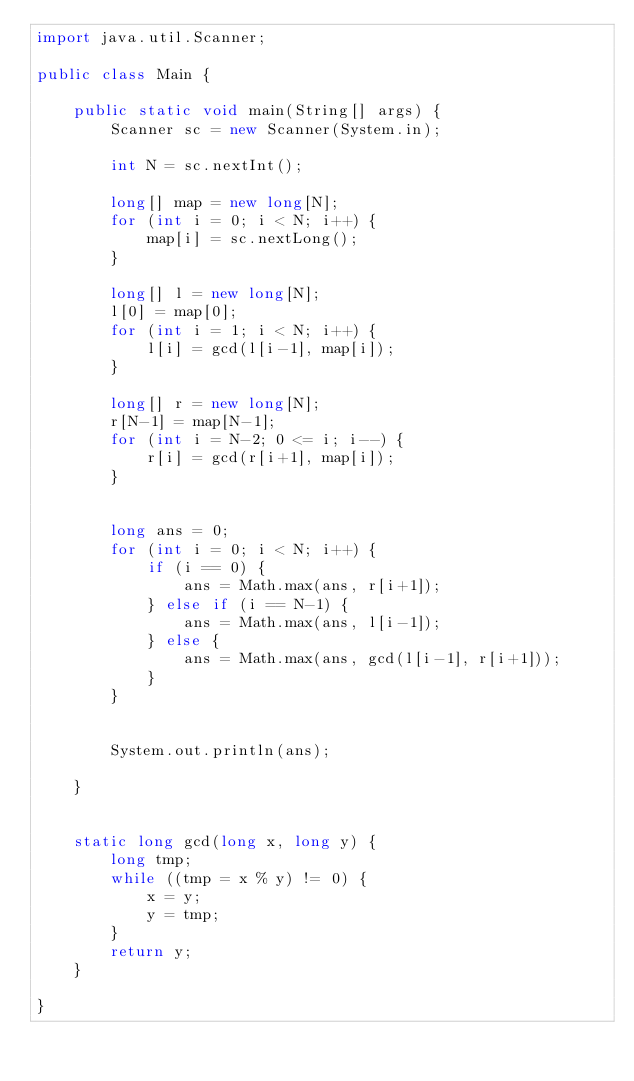<code> <loc_0><loc_0><loc_500><loc_500><_Java_>import java.util.Scanner;

public class Main {

	public static void main(String[] args) {
		Scanner sc = new Scanner(System.in);
		
		int N = sc.nextInt();
		
		long[] map = new long[N];
		for (int i = 0; i < N; i++) {
			map[i] = sc.nextLong();
		}
		
		long[] l = new long[N];
		l[0] = map[0];
		for (int i = 1; i < N; i++) {
			l[i] = gcd(l[i-1], map[i]);
		}
		
		long[] r = new long[N];
		r[N-1] = map[N-1];
		for (int i = N-2; 0 <= i; i--) {
			r[i] = gcd(r[i+1], map[i]);
		}
		
		
		long ans = 0;
		for (int i = 0; i < N; i++) {
			if (i == 0) {
				ans = Math.max(ans, r[i+1]);
			} else if (i == N-1) {
				ans = Math.max(ans, l[i-1]);
			} else {
				ans = Math.max(ans, gcd(l[i-1], r[i+1]));
			}
		}
		
		
		System.out.println(ans);
		
	}
	
	
	static long gcd(long x, long y) {
		long tmp;
        while ((tmp = x % y) != 0) {
            x = y;
            y = tmp;
        }
        return y;
	}
	
}

</code> 